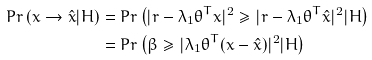Convert formula to latex. <formula><loc_0><loc_0><loc_500><loc_500>P r \left ( x \rightarrow \hat { x } | H \right ) & = P r \left ( | r - \lambda _ { 1 } \theta ^ { T } x | ^ { 2 } \geq | r - \lambda _ { 1 } \theta ^ { T } \hat { x } | ^ { 2 } | H \right ) \\ & = P r \left ( \beta \geq | \lambda _ { 1 } \theta ^ { T } ( x - \hat { x } ) | ^ { 2 } | H \right )</formula> 